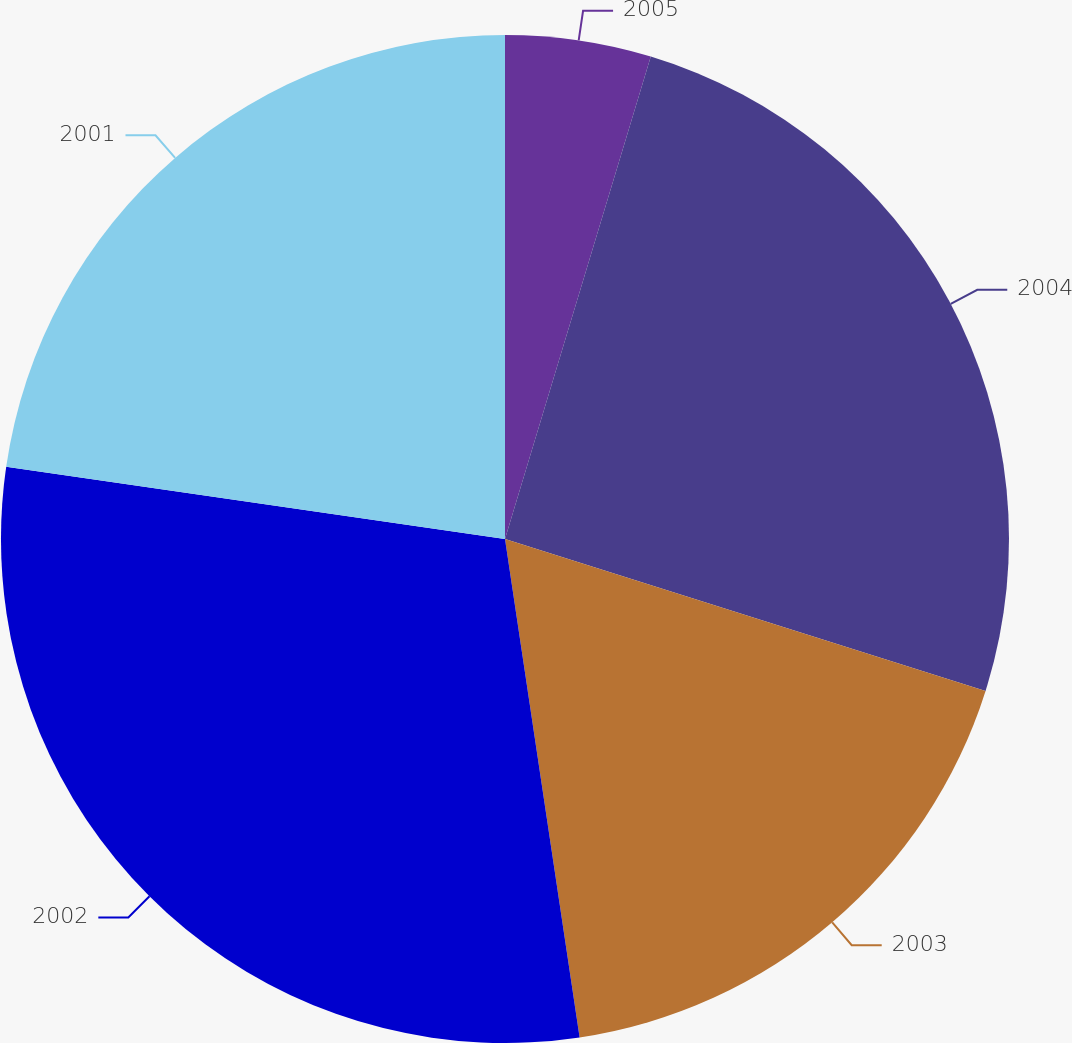Convert chart to OTSL. <chart><loc_0><loc_0><loc_500><loc_500><pie_chart><fcel>2005<fcel>2004<fcel>2003<fcel>2002<fcel>2001<nl><fcel>4.67%<fcel>25.2%<fcel>17.76%<fcel>29.65%<fcel>22.71%<nl></chart> 